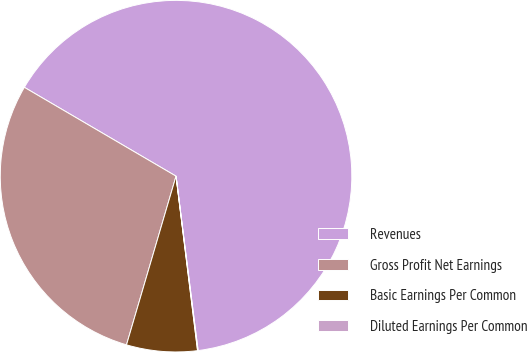Convert chart. <chart><loc_0><loc_0><loc_500><loc_500><pie_chart><fcel>Revenues<fcel>Gross Profit Net Earnings<fcel>Basic Earnings Per Common<fcel>Diluted Earnings Per Common<nl><fcel>64.57%<fcel>28.89%<fcel>6.5%<fcel>0.05%<nl></chart> 